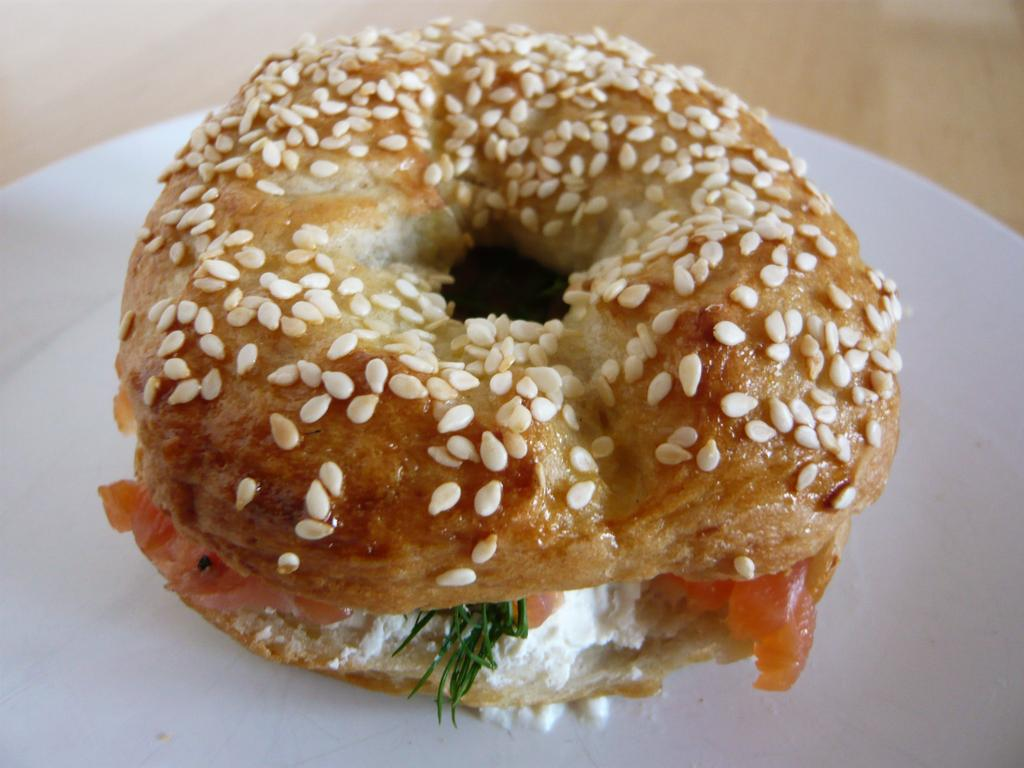What is present on the plate in the image? The food is on a plate in the image. What type of surface is the plate resting on? The plate is on a wooden surface. What type of pain is the food experiencing in the image? The food is not capable of experiencing pain, as it is an inanimate object. 